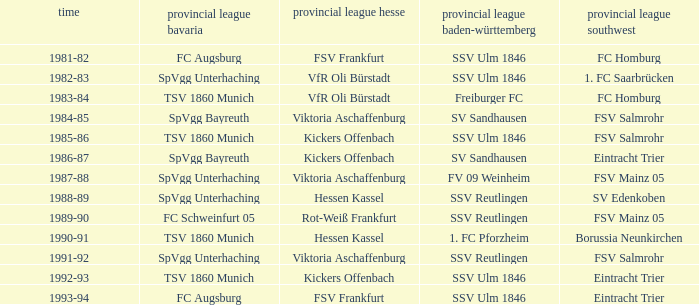Which oberliga südwes has an oberliga baden-württemberg of sv sandhausen in 1984-85? FSV Salmrohr. 